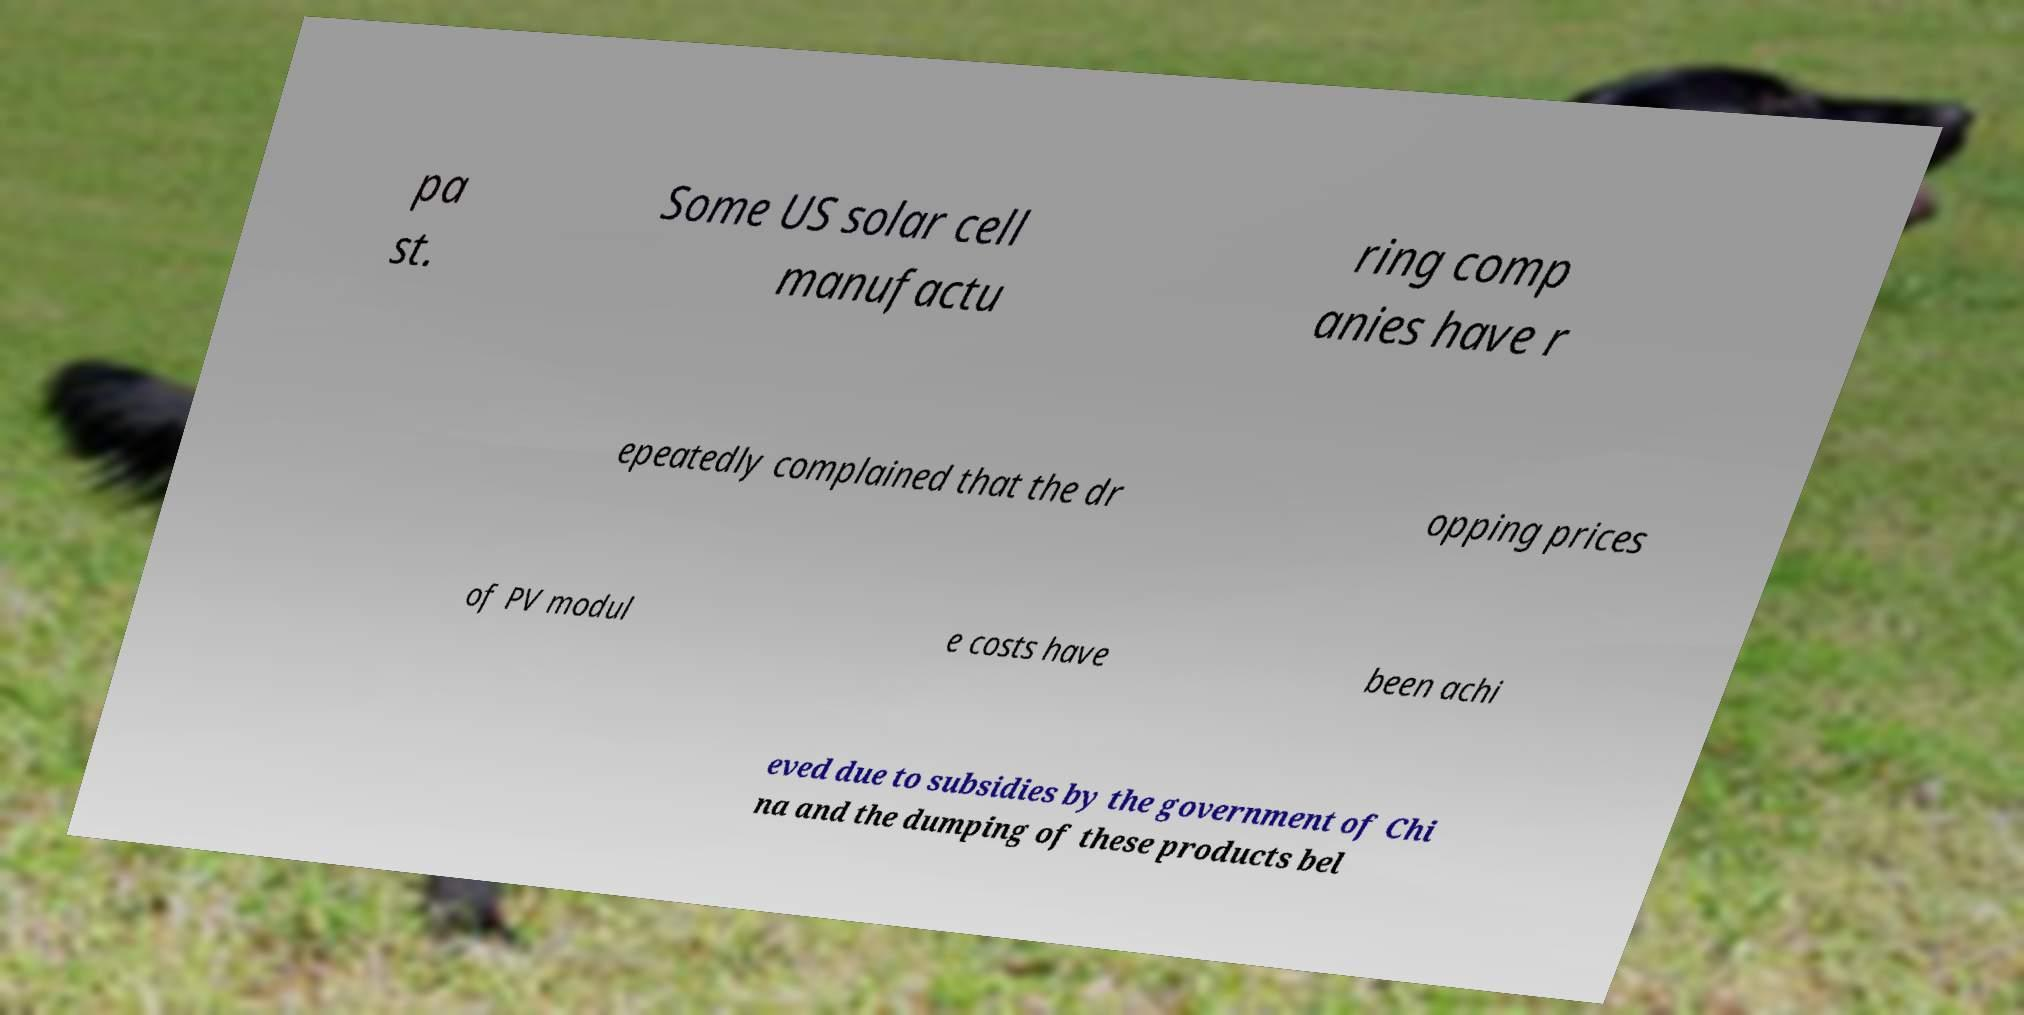Could you assist in decoding the text presented in this image and type it out clearly? pa st. Some US solar cell manufactu ring comp anies have r epeatedly complained that the dr opping prices of PV modul e costs have been achi eved due to subsidies by the government of Chi na and the dumping of these products bel 